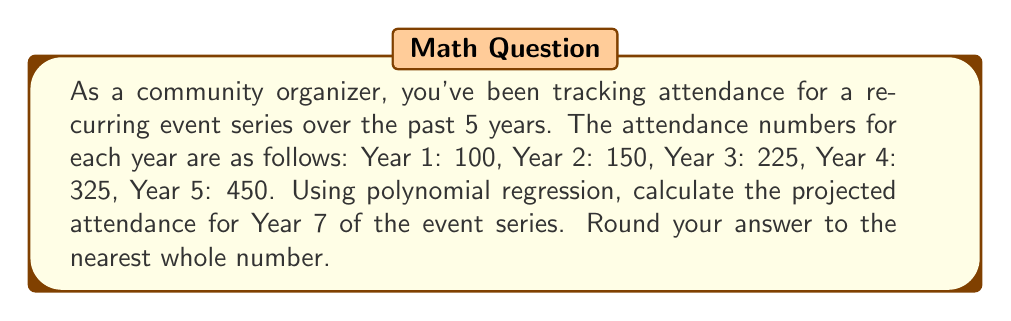Can you solve this math problem? To solve this problem, we'll use quadratic polynomial regression, which is appropriate for this growth pattern. Let's follow these steps:

1) Let x represent the year (1, 2, 3, 4, 5) and y represent the attendance.

2) We'll use the general form of a quadratic equation: $y = ax^2 + bx + c$

3) To find a, b, and c, we need to solve the following system of equations:

   $$\sum y = an^2 + bn + nc$$
   $$\sum xy = a\sum x^3 + b\sum x^2 + c\sum x$$
   $$\sum x^2y = a\sum x^4 + b\sum x^3 + c\sum x^2$$

4) Calculate the necessary sums:
   $\sum x = 15$, $\sum x^2 = 55$, $\sum x^3 = 225$, $\sum x^4 = 979$
   $\sum y = 1250$, $\sum xy = 4675$, $\sum x^2y = 18625$

5) Substitute these values into the system of equations:

   $$1250 = 55a + 15b + 5c$$
   $$4675 = 225a + 55b + 15c$$
   $$18625 = 979a + 225b + 55c$$

6) Solve this system of equations (using a calculator or computer algebra system) to get:
   $a = 10.71429$, $b = 13.92857$, $c = 77.85714$

7) Our quadratic regression equation is:
   $$y = 10.71429x^2 + 13.92857x + 77.85714$$

8) To project attendance for Year 7, substitute x = 7:
   $$y = 10.71429(7^2) + 13.92857(7) + 77.85714$$
   $$y = 10.71429(49) + 13.92857(7) + 77.85714$$
   $$y = 524.99991 + 97.49999 + 77.85714$$
   $$y = 700.35704$$

9) Rounding to the nearest whole number: 700
Answer: 700 